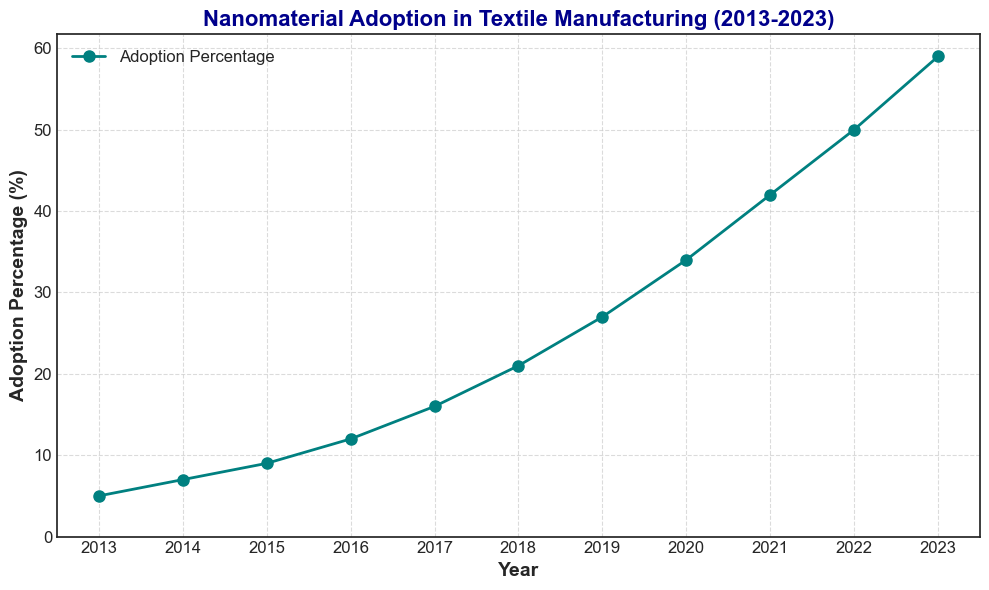What's the pattern in the trend of nanomaterial adoption in textile manufacturing from 2013 to 2023? Observing the curve in the figure, the adoption percentage consistently increases every year, indicating a steadily rising trend.
Answer: The adoption percentage increases every year How much did the adoption percentage increase from 2019 to 2020? Subtract the adoption percentage in 2019 (27%) from the adoption percentage in 2020 (34%). The difference is 34 - 27 = 7.
Answer: 7% Which year had the highest nanomaterial adoption percentage? From the figure, the adoption percentage is plotted against years, and 2023 is the highest point at 59%.
Answer: 2023 By what factor did the adoption percentage increase from 2013 to 2023? Divide the adoption percentage in 2023 (59%) by that in 2013 (5%). The factor is 59 / 5 = 11.8.
Answer: 11.8 Was the increase in adoption percentage from 2017 to 2018 greater than from 2018 to 2019? Calculate the increase from 2017 to 2018 (21% - 16% = 5%) and from 2018 to 2019 (27% - 21% = 6%). Comparing these, 6% is greater than 5%.
Answer: No Which year saw the largest single-year increase in adoption percentage? Comparing the yearly increases: 
2013 to 2014: 2%, 
2014 to 2015: 2%, 
2015 to 2016: 3%, 
2016 to 2017: 4%, 
2017 to 2018: 5%, 
2018 to 2019: 6%, 
2019 to 2020: 7%, 
2020 to 2021: 8%, 
2021 to 2022: 8%, 
2022 to 2023: 9%. The largest increase is 9% from 2022 to 2023.
Answer: 2022 to 2023 What's the average nanomaterial adoption percentage over the last decade? Sum the adoption percentages from 2013 to 2023 and divide by the number of years. Total sum = 5 + 7 + 9 + 12 + 16 + 21 + 27 + 34 + 42 + 50 + 59 = 282. Average = 282/11 = approximately 25.6%.
Answer: Approximately 25.6% Did the adoption percentage increase by more than 10% between any consecutive years? Check each year's increase:
2013 to 2014: 2%,
2014 to 2015: 2%,
2015 to 2016: 3%,
2016 to 2017: 4%,
2017 to 2018: 5%,
2018 to 2019: 6%,
2019 to 2020: 7%,
2020 to 2021: 8%,
2021 to 2022: 8%,
2022 to 2023: 9%. No increase is greater than 10%.
Answer: No What was the adoption percentage halfway between the years 2015 and 2018? For halfway between years, calculate the midpoint. The midpoint year between 2015 and 2018 is 2016.5 (which rounds to 2017). The adoption percentage in 2017 is 16%.
Answer: 16% 